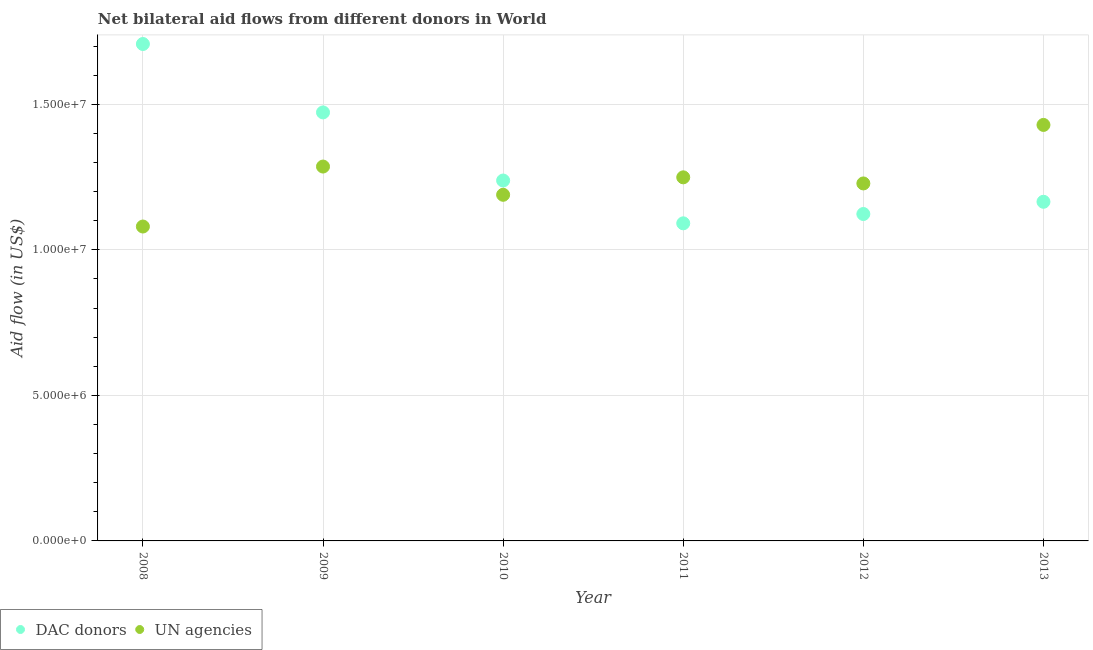How many different coloured dotlines are there?
Your answer should be very brief. 2. What is the aid flow from un agencies in 2009?
Give a very brief answer. 1.29e+07. Across all years, what is the maximum aid flow from dac donors?
Offer a very short reply. 1.71e+07. Across all years, what is the minimum aid flow from dac donors?
Provide a succinct answer. 1.09e+07. In which year was the aid flow from dac donors maximum?
Provide a short and direct response. 2008. In which year was the aid flow from un agencies minimum?
Your response must be concise. 2008. What is the total aid flow from dac donors in the graph?
Make the answer very short. 7.80e+07. What is the difference between the aid flow from dac donors in 2008 and that in 2012?
Keep it short and to the point. 5.84e+06. What is the difference between the aid flow from dac donors in 2010 and the aid flow from un agencies in 2009?
Provide a short and direct response. -4.80e+05. What is the average aid flow from un agencies per year?
Provide a short and direct response. 1.24e+07. In the year 2009, what is the difference between the aid flow from un agencies and aid flow from dac donors?
Ensure brevity in your answer.  -1.86e+06. In how many years, is the aid flow from dac donors greater than 8000000 US$?
Your answer should be very brief. 6. What is the ratio of the aid flow from un agencies in 2012 to that in 2013?
Offer a very short reply. 0.86. Is the aid flow from dac donors in 2008 less than that in 2009?
Your answer should be very brief. No. What is the difference between the highest and the second highest aid flow from un agencies?
Your answer should be very brief. 1.43e+06. What is the difference between the highest and the lowest aid flow from un agencies?
Provide a short and direct response. 3.49e+06. In how many years, is the aid flow from un agencies greater than the average aid flow from un agencies taken over all years?
Your response must be concise. 3. Is the sum of the aid flow from un agencies in 2009 and 2013 greater than the maximum aid flow from dac donors across all years?
Make the answer very short. Yes. Is the aid flow from dac donors strictly greater than the aid flow from un agencies over the years?
Your answer should be very brief. No. Is the aid flow from un agencies strictly less than the aid flow from dac donors over the years?
Give a very brief answer. No. How many dotlines are there?
Give a very brief answer. 2. How many legend labels are there?
Ensure brevity in your answer.  2. What is the title of the graph?
Provide a succinct answer. Net bilateral aid flows from different donors in World. What is the label or title of the X-axis?
Give a very brief answer. Year. What is the label or title of the Y-axis?
Offer a terse response. Aid flow (in US$). What is the Aid flow (in US$) in DAC donors in 2008?
Your answer should be compact. 1.71e+07. What is the Aid flow (in US$) in UN agencies in 2008?
Make the answer very short. 1.08e+07. What is the Aid flow (in US$) in DAC donors in 2009?
Keep it short and to the point. 1.47e+07. What is the Aid flow (in US$) of UN agencies in 2009?
Offer a terse response. 1.29e+07. What is the Aid flow (in US$) in DAC donors in 2010?
Ensure brevity in your answer.  1.24e+07. What is the Aid flow (in US$) of UN agencies in 2010?
Your response must be concise. 1.19e+07. What is the Aid flow (in US$) of DAC donors in 2011?
Keep it short and to the point. 1.09e+07. What is the Aid flow (in US$) in UN agencies in 2011?
Your answer should be compact. 1.25e+07. What is the Aid flow (in US$) of DAC donors in 2012?
Keep it short and to the point. 1.12e+07. What is the Aid flow (in US$) in UN agencies in 2012?
Provide a succinct answer. 1.23e+07. What is the Aid flow (in US$) of DAC donors in 2013?
Keep it short and to the point. 1.16e+07. What is the Aid flow (in US$) of UN agencies in 2013?
Offer a very short reply. 1.43e+07. Across all years, what is the maximum Aid flow (in US$) of DAC donors?
Keep it short and to the point. 1.71e+07. Across all years, what is the maximum Aid flow (in US$) of UN agencies?
Ensure brevity in your answer.  1.43e+07. Across all years, what is the minimum Aid flow (in US$) of DAC donors?
Your response must be concise. 1.09e+07. Across all years, what is the minimum Aid flow (in US$) in UN agencies?
Keep it short and to the point. 1.08e+07. What is the total Aid flow (in US$) of DAC donors in the graph?
Provide a succinct answer. 7.80e+07. What is the total Aid flow (in US$) of UN agencies in the graph?
Your answer should be very brief. 7.46e+07. What is the difference between the Aid flow (in US$) of DAC donors in 2008 and that in 2009?
Provide a succinct answer. 2.35e+06. What is the difference between the Aid flow (in US$) in UN agencies in 2008 and that in 2009?
Ensure brevity in your answer.  -2.06e+06. What is the difference between the Aid flow (in US$) of DAC donors in 2008 and that in 2010?
Keep it short and to the point. 4.69e+06. What is the difference between the Aid flow (in US$) in UN agencies in 2008 and that in 2010?
Offer a very short reply. -1.09e+06. What is the difference between the Aid flow (in US$) in DAC donors in 2008 and that in 2011?
Your answer should be compact. 6.16e+06. What is the difference between the Aid flow (in US$) in UN agencies in 2008 and that in 2011?
Your response must be concise. -1.69e+06. What is the difference between the Aid flow (in US$) of DAC donors in 2008 and that in 2012?
Make the answer very short. 5.84e+06. What is the difference between the Aid flow (in US$) of UN agencies in 2008 and that in 2012?
Your answer should be compact. -1.48e+06. What is the difference between the Aid flow (in US$) in DAC donors in 2008 and that in 2013?
Your answer should be very brief. 5.42e+06. What is the difference between the Aid flow (in US$) of UN agencies in 2008 and that in 2013?
Your answer should be compact. -3.49e+06. What is the difference between the Aid flow (in US$) of DAC donors in 2009 and that in 2010?
Provide a short and direct response. 2.34e+06. What is the difference between the Aid flow (in US$) of UN agencies in 2009 and that in 2010?
Offer a terse response. 9.70e+05. What is the difference between the Aid flow (in US$) of DAC donors in 2009 and that in 2011?
Provide a short and direct response. 3.81e+06. What is the difference between the Aid flow (in US$) in DAC donors in 2009 and that in 2012?
Make the answer very short. 3.49e+06. What is the difference between the Aid flow (in US$) of UN agencies in 2009 and that in 2012?
Provide a short and direct response. 5.80e+05. What is the difference between the Aid flow (in US$) in DAC donors in 2009 and that in 2013?
Make the answer very short. 3.07e+06. What is the difference between the Aid flow (in US$) of UN agencies in 2009 and that in 2013?
Give a very brief answer. -1.43e+06. What is the difference between the Aid flow (in US$) of DAC donors in 2010 and that in 2011?
Offer a terse response. 1.47e+06. What is the difference between the Aid flow (in US$) of UN agencies in 2010 and that in 2011?
Provide a succinct answer. -6.00e+05. What is the difference between the Aid flow (in US$) in DAC donors in 2010 and that in 2012?
Ensure brevity in your answer.  1.15e+06. What is the difference between the Aid flow (in US$) in UN agencies in 2010 and that in 2012?
Offer a very short reply. -3.90e+05. What is the difference between the Aid flow (in US$) in DAC donors in 2010 and that in 2013?
Make the answer very short. 7.30e+05. What is the difference between the Aid flow (in US$) in UN agencies in 2010 and that in 2013?
Your response must be concise. -2.40e+06. What is the difference between the Aid flow (in US$) of DAC donors in 2011 and that in 2012?
Give a very brief answer. -3.20e+05. What is the difference between the Aid flow (in US$) in UN agencies in 2011 and that in 2012?
Make the answer very short. 2.10e+05. What is the difference between the Aid flow (in US$) of DAC donors in 2011 and that in 2013?
Offer a terse response. -7.40e+05. What is the difference between the Aid flow (in US$) in UN agencies in 2011 and that in 2013?
Keep it short and to the point. -1.80e+06. What is the difference between the Aid flow (in US$) of DAC donors in 2012 and that in 2013?
Your answer should be compact. -4.20e+05. What is the difference between the Aid flow (in US$) of UN agencies in 2012 and that in 2013?
Your answer should be compact. -2.01e+06. What is the difference between the Aid flow (in US$) in DAC donors in 2008 and the Aid flow (in US$) in UN agencies in 2009?
Keep it short and to the point. 4.21e+06. What is the difference between the Aid flow (in US$) in DAC donors in 2008 and the Aid flow (in US$) in UN agencies in 2010?
Your response must be concise. 5.18e+06. What is the difference between the Aid flow (in US$) in DAC donors in 2008 and the Aid flow (in US$) in UN agencies in 2011?
Your answer should be compact. 4.58e+06. What is the difference between the Aid flow (in US$) in DAC donors in 2008 and the Aid flow (in US$) in UN agencies in 2012?
Provide a short and direct response. 4.79e+06. What is the difference between the Aid flow (in US$) of DAC donors in 2008 and the Aid flow (in US$) of UN agencies in 2013?
Provide a short and direct response. 2.78e+06. What is the difference between the Aid flow (in US$) in DAC donors in 2009 and the Aid flow (in US$) in UN agencies in 2010?
Keep it short and to the point. 2.83e+06. What is the difference between the Aid flow (in US$) in DAC donors in 2009 and the Aid flow (in US$) in UN agencies in 2011?
Give a very brief answer. 2.23e+06. What is the difference between the Aid flow (in US$) of DAC donors in 2009 and the Aid flow (in US$) of UN agencies in 2012?
Provide a succinct answer. 2.44e+06. What is the difference between the Aid flow (in US$) of DAC donors in 2010 and the Aid flow (in US$) of UN agencies in 2011?
Make the answer very short. -1.10e+05. What is the difference between the Aid flow (in US$) in DAC donors in 2010 and the Aid flow (in US$) in UN agencies in 2012?
Your answer should be compact. 1.00e+05. What is the difference between the Aid flow (in US$) in DAC donors in 2010 and the Aid flow (in US$) in UN agencies in 2013?
Your response must be concise. -1.91e+06. What is the difference between the Aid flow (in US$) of DAC donors in 2011 and the Aid flow (in US$) of UN agencies in 2012?
Your answer should be compact. -1.37e+06. What is the difference between the Aid flow (in US$) in DAC donors in 2011 and the Aid flow (in US$) in UN agencies in 2013?
Provide a succinct answer. -3.38e+06. What is the difference between the Aid flow (in US$) of DAC donors in 2012 and the Aid flow (in US$) of UN agencies in 2013?
Keep it short and to the point. -3.06e+06. What is the average Aid flow (in US$) of DAC donors per year?
Make the answer very short. 1.30e+07. What is the average Aid flow (in US$) of UN agencies per year?
Your response must be concise. 1.24e+07. In the year 2008, what is the difference between the Aid flow (in US$) of DAC donors and Aid flow (in US$) of UN agencies?
Ensure brevity in your answer.  6.27e+06. In the year 2009, what is the difference between the Aid flow (in US$) in DAC donors and Aid flow (in US$) in UN agencies?
Give a very brief answer. 1.86e+06. In the year 2010, what is the difference between the Aid flow (in US$) of DAC donors and Aid flow (in US$) of UN agencies?
Offer a terse response. 4.90e+05. In the year 2011, what is the difference between the Aid flow (in US$) in DAC donors and Aid flow (in US$) in UN agencies?
Provide a succinct answer. -1.58e+06. In the year 2012, what is the difference between the Aid flow (in US$) of DAC donors and Aid flow (in US$) of UN agencies?
Provide a short and direct response. -1.05e+06. In the year 2013, what is the difference between the Aid flow (in US$) of DAC donors and Aid flow (in US$) of UN agencies?
Your answer should be compact. -2.64e+06. What is the ratio of the Aid flow (in US$) in DAC donors in 2008 to that in 2009?
Offer a terse response. 1.16. What is the ratio of the Aid flow (in US$) of UN agencies in 2008 to that in 2009?
Provide a short and direct response. 0.84. What is the ratio of the Aid flow (in US$) in DAC donors in 2008 to that in 2010?
Provide a succinct answer. 1.38. What is the ratio of the Aid flow (in US$) in UN agencies in 2008 to that in 2010?
Provide a succinct answer. 0.91. What is the ratio of the Aid flow (in US$) of DAC donors in 2008 to that in 2011?
Give a very brief answer. 1.56. What is the ratio of the Aid flow (in US$) in UN agencies in 2008 to that in 2011?
Your answer should be very brief. 0.86. What is the ratio of the Aid flow (in US$) in DAC donors in 2008 to that in 2012?
Your answer should be very brief. 1.52. What is the ratio of the Aid flow (in US$) of UN agencies in 2008 to that in 2012?
Make the answer very short. 0.88. What is the ratio of the Aid flow (in US$) in DAC donors in 2008 to that in 2013?
Your response must be concise. 1.47. What is the ratio of the Aid flow (in US$) of UN agencies in 2008 to that in 2013?
Your response must be concise. 0.76. What is the ratio of the Aid flow (in US$) of DAC donors in 2009 to that in 2010?
Offer a terse response. 1.19. What is the ratio of the Aid flow (in US$) of UN agencies in 2009 to that in 2010?
Offer a terse response. 1.08. What is the ratio of the Aid flow (in US$) in DAC donors in 2009 to that in 2011?
Keep it short and to the point. 1.35. What is the ratio of the Aid flow (in US$) in UN agencies in 2009 to that in 2011?
Offer a terse response. 1.03. What is the ratio of the Aid flow (in US$) of DAC donors in 2009 to that in 2012?
Your answer should be compact. 1.31. What is the ratio of the Aid flow (in US$) of UN agencies in 2009 to that in 2012?
Offer a very short reply. 1.05. What is the ratio of the Aid flow (in US$) of DAC donors in 2009 to that in 2013?
Your answer should be compact. 1.26. What is the ratio of the Aid flow (in US$) of UN agencies in 2009 to that in 2013?
Keep it short and to the point. 0.9. What is the ratio of the Aid flow (in US$) in DAC donors in 2010 to that in 2011?
Make the answer very short. 1.13. What is the ratio of the Aid flow (in US$) in DAC donors in 2010 to that in 2012?
Give a very brief answer. 1.1. What is the ratio of the Aid flow (in US$) of UN agencies in 2010 to that in 2012?
Provide a short and direct response. 0.97. What is the ratio of the Aid flow (in US$) in DAC donors in 2010 to that in 2013?
Give a very brief answer. 1.06. What is the ratio of the Aid flow (in US$) in UN agencies in 2010 to that in 2013?
Your answer should be compact. 0.83. What is the ratio of the Aid flow (in US$) in DAC donors in 2011 to that in 2012?
Your answer should be very brief. 0.97. What is the ratio of the Aid flow (in US$) of UN agencies in 2011 to that in 2012?
Provide a succinct answer. 1.02. What is the ratio of the Aid flow (in US$) of DAC donors in 2011 to that in 2013?
Keep it short and to the point. 0.94. What is the ratio of the Aid flow (in US$) in UN agencies in 2011 to that in 2013?
Make the answer very short. 0.87. What is the ratio of the Aid flow (in US$) of DAC donors in 2012 to that in 2013?
Provide a short and direct response. 0.96. What is the ratio of the Aid flow (in US$) in UN agencies in 2012 to that in 2013?
Ensure brevity in your answer.  0.86. What is the difference between the highest and the second highest Aid flow (in US$) in DAC donors?
Provide a succinct answer. 2.35e+06. What is the difference between the highest and the second highest Aid flow (in US$) of UN agencies?
Ensure brevity in your answer.  1.43e+06. What is the difference between the highest and the lowest Aid flow (in US$) in DAC donors?
Provide a short and direct response. 6.16e+06. What is the difference between the highest and the lowest Aid flow (in US$) in UN agencies?
Provide a short and direct response. 3.49e+06. 